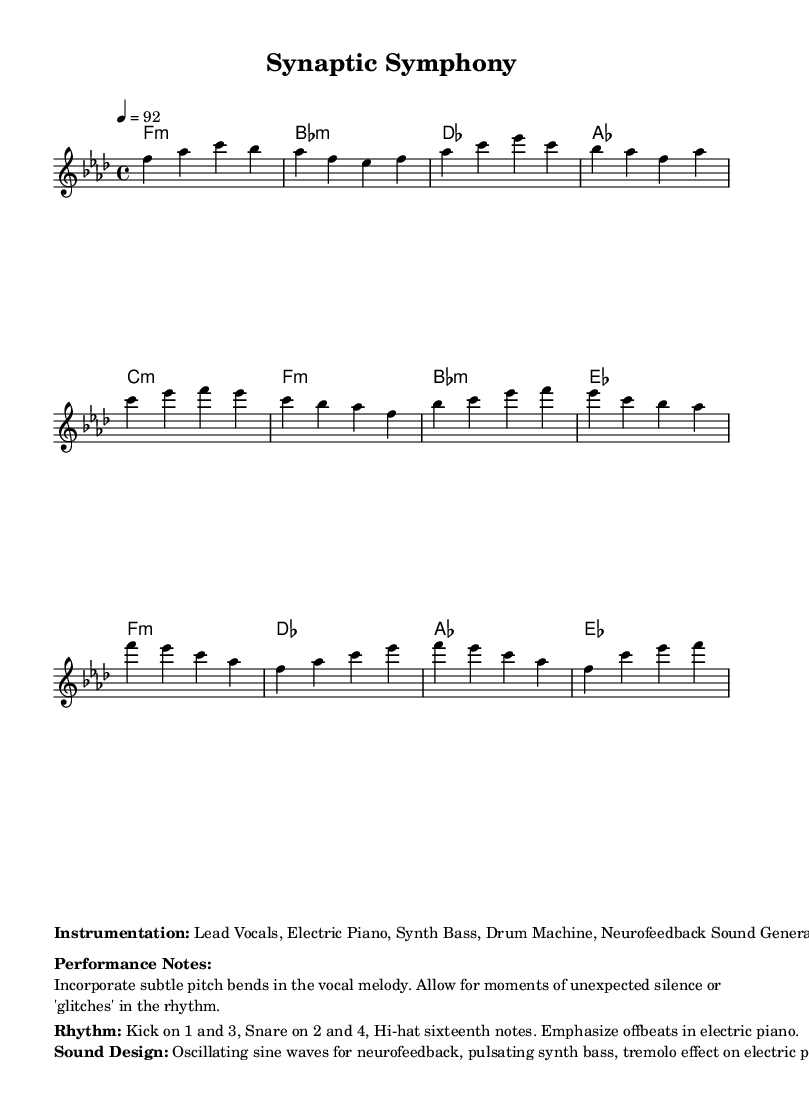What is the key signature of this music? The key signature is F minor, which has four flats (B♭, E♭, A♭, and D♭). This is indicated by the key signature at the beginning of the staff.
Answer: F minor What is the time signature of this music? The time signature is 4/4, which appears at the beginning of the score. This means that each measure contains four beats, and the quarter note gets one beat.
Answer: 4/4 What tempo marking is used in this piece? The tempo marking is 92 beats per minute, denoted at the start of the score with the indication "4 = 92." This tells performers the speed of the piece.
Answer: 92 What is the rhythmic pattern of the drums? The rhythmic pattern for the drums consists of kicks on beats 1 and 3, and snare on beats 2 and 4, with hi-hats playing sixteenth notes. This is indicated in the performance notes section.
Answer: Kick on 1 and 3, Snare on 2 and 4 How many measures are in the chorus section? The chorus has four measures, as seen in the notation provided for the chorus section, which consists of four distinct patterns separated by bars.
Answer: 4 measures What effect is suggested for the electric piano in this piece? A tremolo effect is suggested for the electric piano, as noted in the sound design section, which indicates a specific sound characteristic to be used during performance.
Answer: Tremolo effect What type of sound generator is included in the instrumentation? A neurofeedback sound generator is listed in the instrumentation. This highlights the incorporation of unconventional sound patterns related to neurological rhythms.
Answer: Neurofeedback Sound Generator 